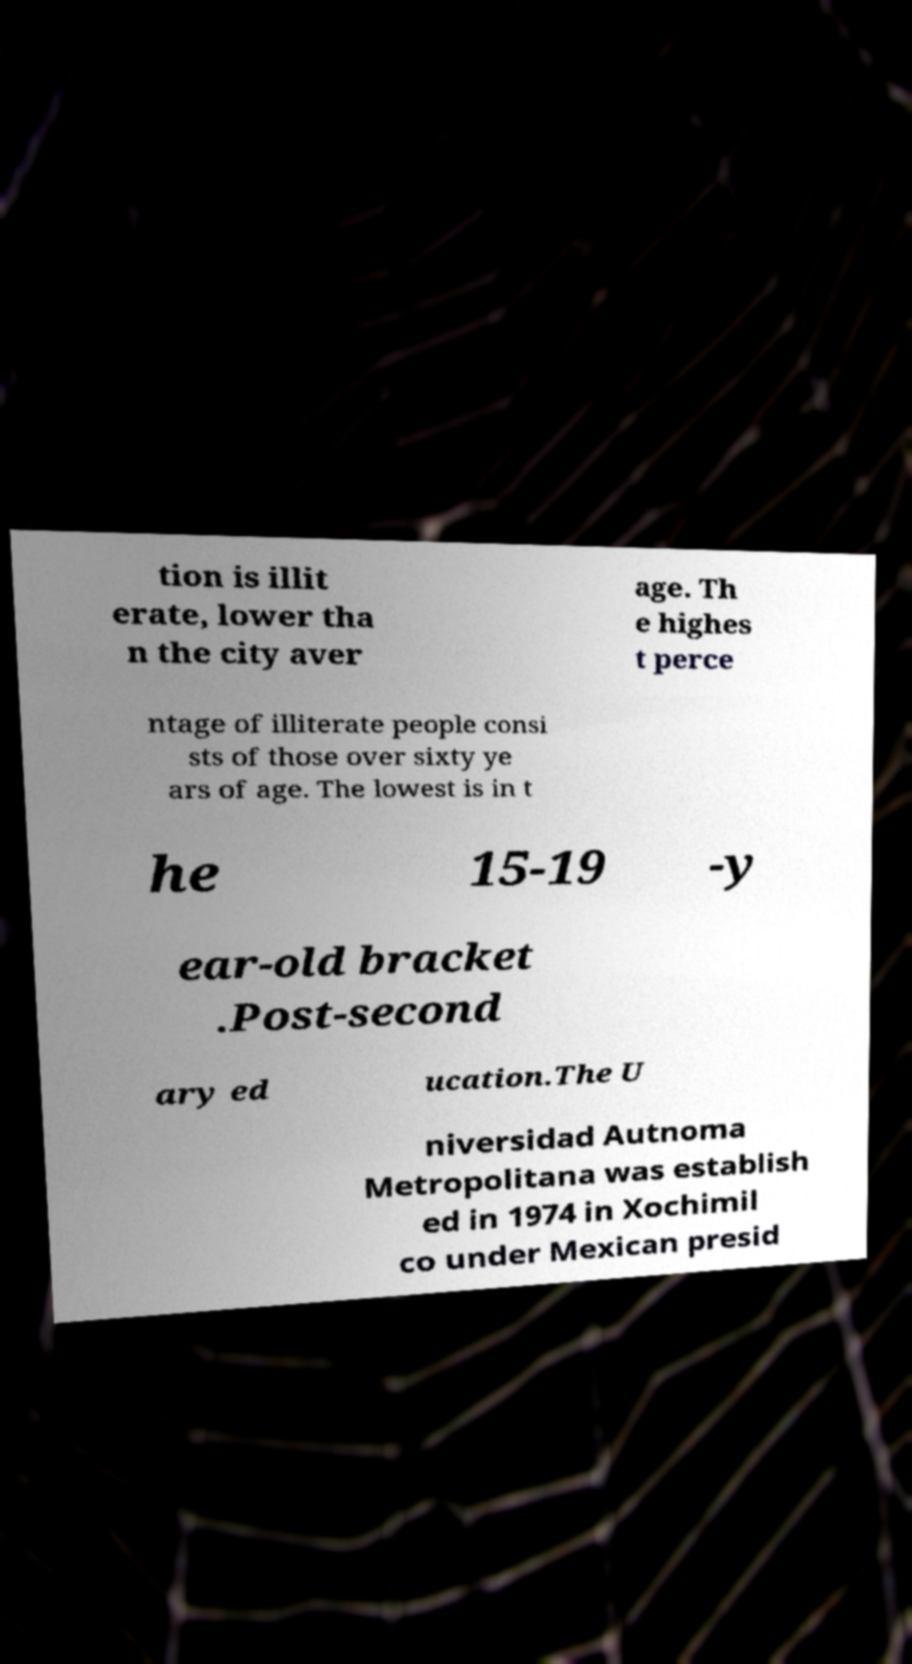I need the written content from this picture converted into text. Can you do that? tion is illit erate, lower tha n the city aver age. Th e highes t perce ntage of illiterate people consi sts of those over sixty ye ars of age. The lowest is in t he 15-19 -y ear-old bracket .Post-second ary ed ucation.The U niversidad Autnoma Metropolitana was establish ed in 1974 in Xochimil co under Mexican presid 